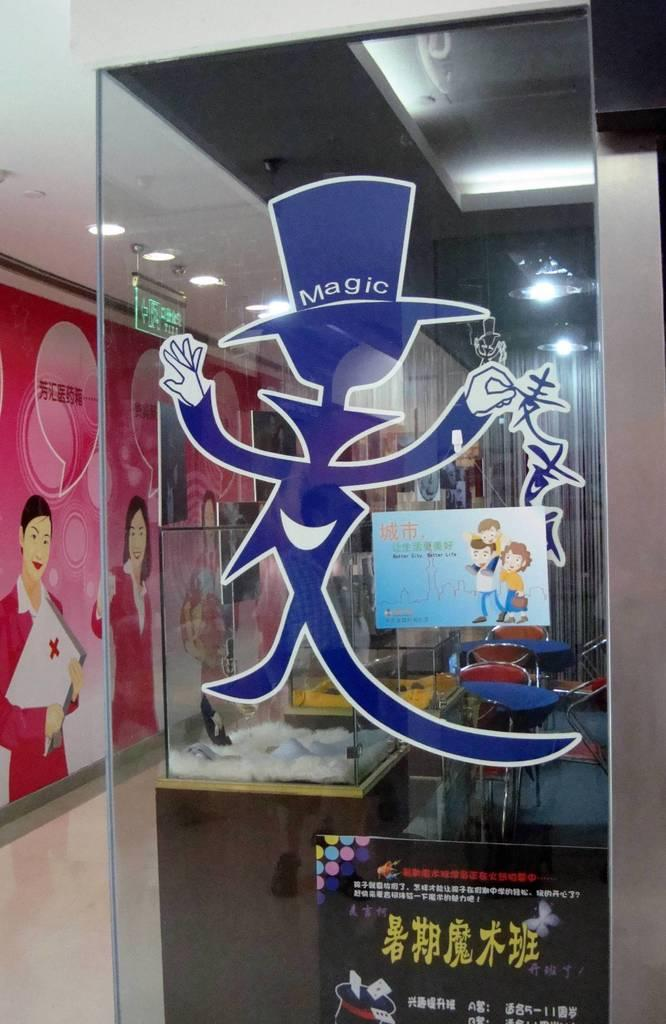<image>
Relay a brief, clear account of the picture shown. Inside a business glass wall office with a magic sticker on a glass wall in purple. 